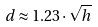Convert formula to latex. <formula><loc_0><loc_0><loc_500><loc_500>d \approx 1 . 2 3 \cdot \sqrt { h }</formula> 